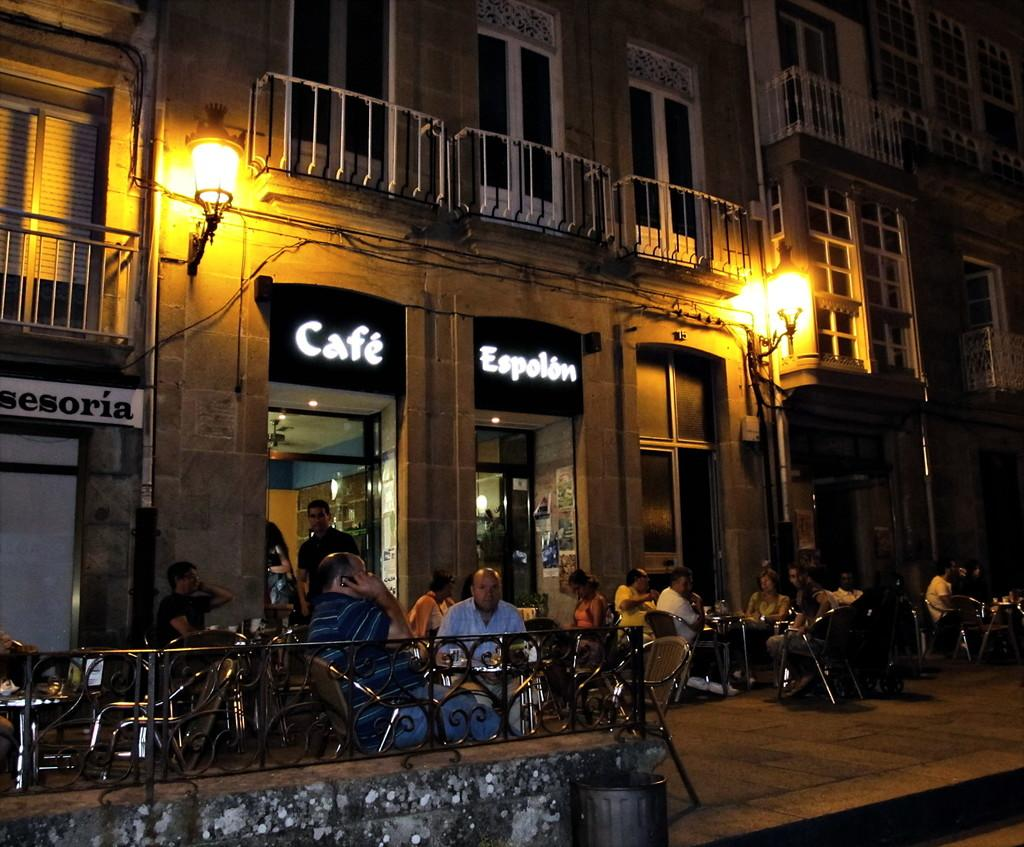<image>
Provide a brief description of the given image. a street scene with side walk tables in front of Cafe Espolon 